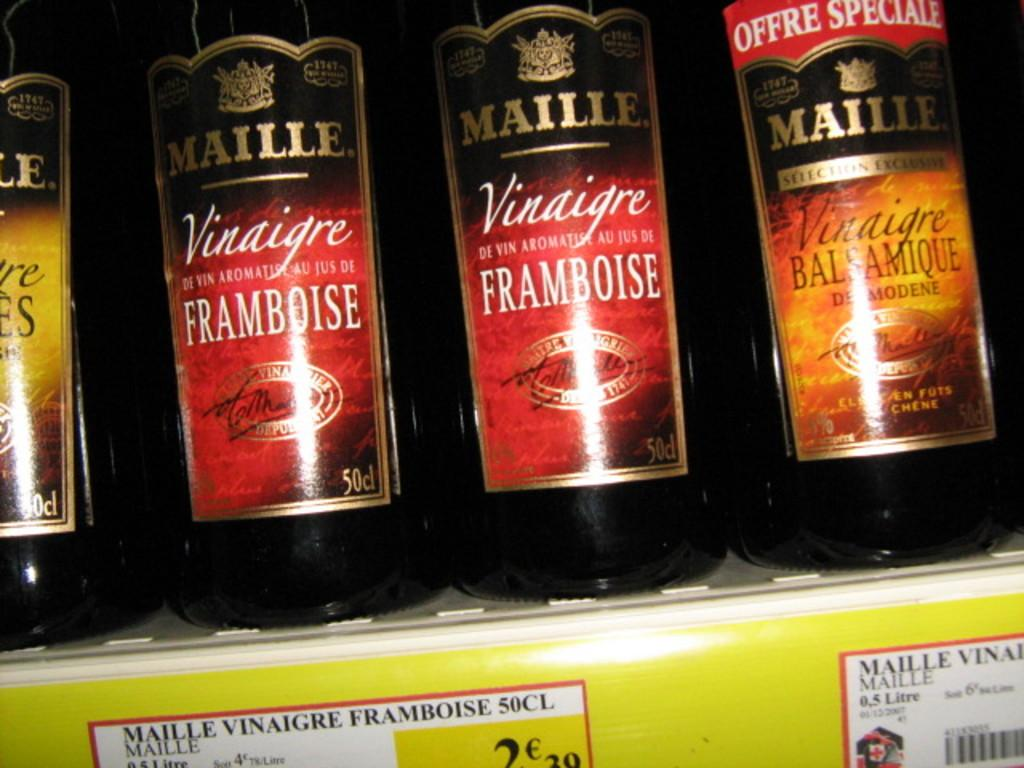<image>
Share a concise interpretation of the image provided. Red and orange labelled Maille bottles sit on a shelf. 